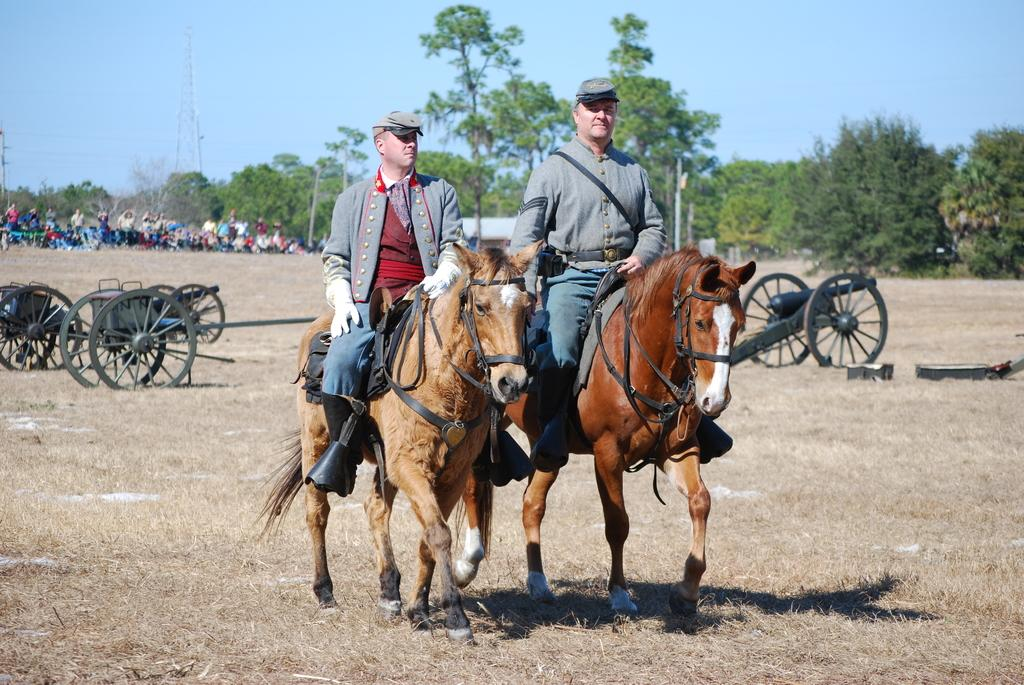How many men are in the image? There are two men in the image. What are the men doing in the image? The men are sitting on horses. What type of headgear are the men wearing? The men are wearing wire caps. What can be seen on the grass in the image? There are objects on the grass. What type of weapons are present in the image? There are cannons in the image. What can be seen in the background of the image? In the background, there are people, trees, poles, a tower, and the sky. What type of fang can be seen in the image? There are no fangs present in the image. What things can be used to create the tower in the image? The tower in the image is already constructed, so it is not possible to determine what things were used to create it from the image alone. 